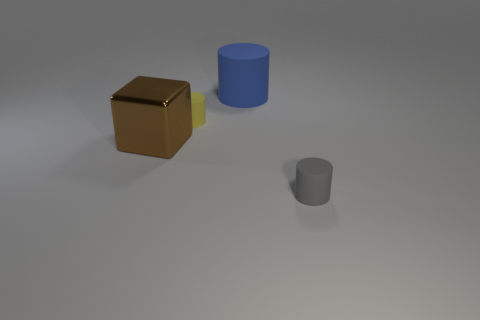Subtract 1 cylinders. How many cylinders are left? 2 Add 4 small gray objects. How many objects exist? 8 Subtract all cylinders. How many objects are left? 1 Add 2 large red spheres. How many large red spheres exist? 2 Subtract 1 yellow cylinders. How many objects are left? 3 Subtract all large green spheres. Subtract all matte cylinders. How many objects are left? 1 Add 1 cylinders. How many cylinders are left? 4 